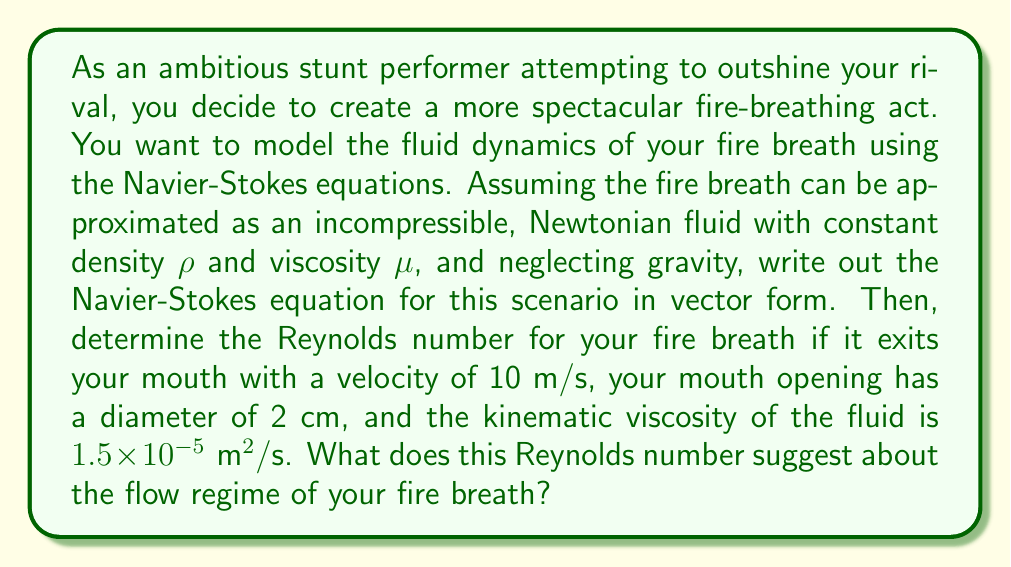Can you answer this question? Let's approach this problem step by step:

1) The Navier-Stokes equation for an incompressible, Newtonian fluid with constant density and viscosity, neglecting gravity, is:

   $$\rho \left(\frac{\partial \mathbf{u}}{\partial t} + \mathbf{u} \cdot \nabla \mathbf{u}\right) = -\nabla p + \mu \nabla^2 \mathbf{u}$$

   Where:
   - $\mathbf{u}$ is the velocity vector
   - $t$ is time
   - $p$ is pressure
   - $\rho$ is density
   - $\mu$ is dynamic viscosity

2) To calculate the Reynolds number, we use the formula:

   $$Re = \frac{\rho U L}{\mu} = \frac{U L}{\nu}$$

   Where:
   - $U$ is the characteristic velocity
   - $L$ is the characteristic length
   - $\nu$ is the kinematic viscosity

3) We are given:
   - $U = 10 \text{ m/s}$
   - $L = 0.02 \text{ m}$ (diameter of mouth opening)
   - $\nu = 1.5 \times 10^{-5} \text{ m}^2/\text{s}$

4) Substituting these values into the Reynolds number equation:

   $$Re = \frac{(10 \text{ m/s})(0.02 \text{ m})}{1.5 \times 10^{-5} \text{ m}^2/\text{s}} = 13,333.33$$

5) The Reynolds number is approximately 13,333, which is well above the critical Reynolds number for pipe flow (typically around 2300). This suggests that the flow of the fire breath is in the turbulent regime.

Turbulent flow is characterized by irregular fluctuations and mixing within the fluid. In the context of a fire-breathing performance, this turbulence would likely contribute to the spectacular, chaotic appearance of the flames, potentially creating a more impressive visual effect than a laminar flow would produce.
Answer: The Navier-Stokes equation for this scenario is:

$$\rho \left(\frac{\partial \mathbf{u}}{\partial t} + \mathbf{u} \cdot \nabla \mathbf{u}\right) = -\nabla p + \mu \nabla^2 \mathbf{u}$$

The Reynolds number is approximately 13,333, indicating turbulent flow. 